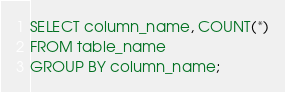Convert code to text. <code><loc_0><loc_0><loc_500><loc_500><_SQL_>SELECT column_name, COUNT(*)
FROM table_name
GROUP BY column_name;</code> 